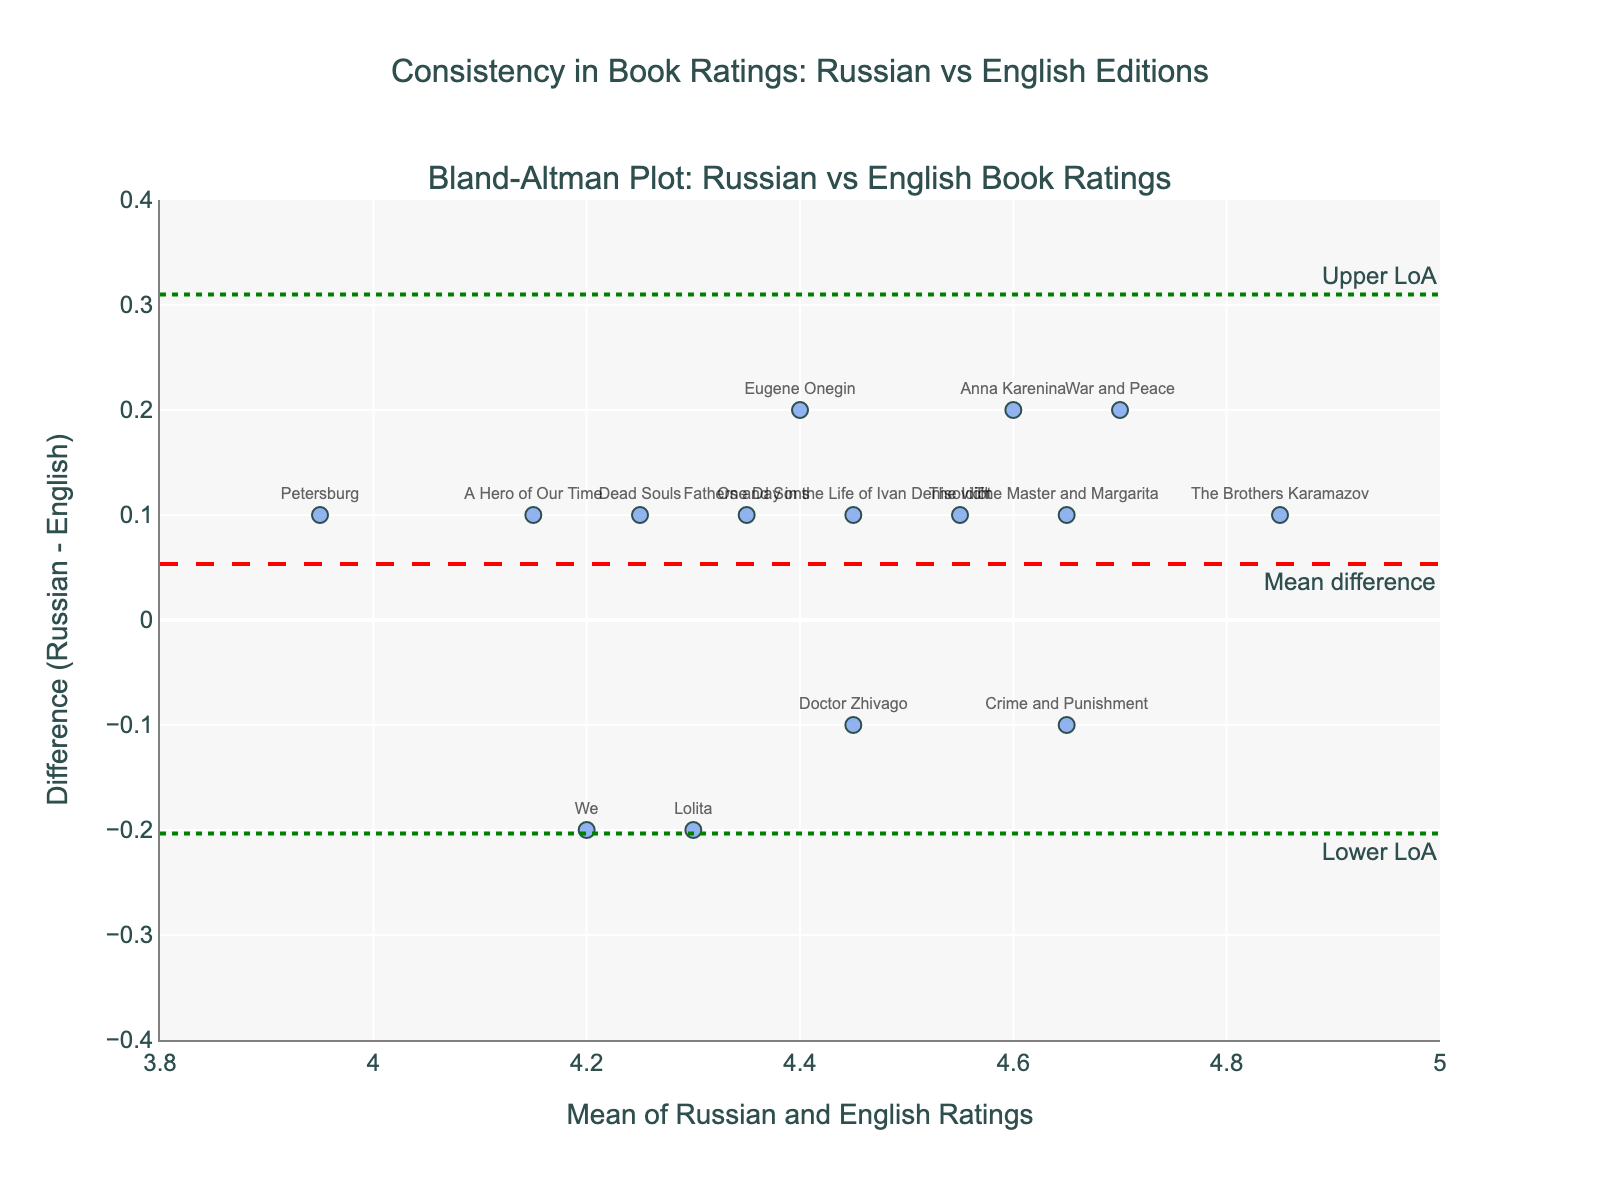How many book titles are represented in the plot? There are 15 book titles listed in the data table. Each title corresponds to a single data point on the Bland-Altman plot.
Answer: 15 What is the mean difference between the Russian and English book ratings? The mean difference is represented by the dashed horizontal line in the plot, annotated as "Mean difference". By observing the position, we can see it is close to 0, meaning the average difference between Russian and English ratings is very small.
Answer: Close to 0 Which book has the largest positive difference (Russian rating higher than English rating)? Observing where the data points are compared to the 0 line, "The Brothers Karamazov" is the highest above the zero line, indicating it has the largest positive difference.
Answer: The Brothers Karamazov Which book has nearly no difference in ratings between the Russian and English editions? The book closest to the zero line in the plot is "Crime and Punishment," meaning its Russian and English ratings are almost equal.
Answer: Crime and Punishment What are the upper and lower limits of agreement for the ratings? The upper and lower limits of agreement are represented by the dotted horizontal lines, annotated as "Upper LoA" and "Lower LoA". By observing these lines, the upper LoA is around 0.2 and the lower LoA is around -0.2.
Answer: Approximately 0.2 and -0.2 How does the difference in ratings for "War and Peace" compare to "Fathers and Sons"? "War and Peace" is above the zero line (positive difference, Russian rating higher), while "Fathers and Sons" is close to the zero line but slightly positive, indicating that "War and Peace" has a greater positive difference than "Fathers and Sons".
Answer: War and Peace has a greater positive difference What can you infer about the consistency in ratings based on the mean difference and limits of agreement? The mean difference close to zero and narrow limits of agreement (around ±0.2) suggest high consistency between Russian and English ratings, meaning ratings are generally similar in both editions with minor deviations.
Answer: High consistency with minor deviations Is there any book with a higher English rating than Russian rating? Yes, "Lolita" is below the zero line, meaning its English rating is higher than its Russian rating.
Answer: Lolita What can you say about the overall trend in the book ratings? Most data points are clustered close to the zero line, meaning there is no systematic bias, and ratings between Russian and English editions are mostly similar.
Answer: No systematic bias, mostly similar ratings 